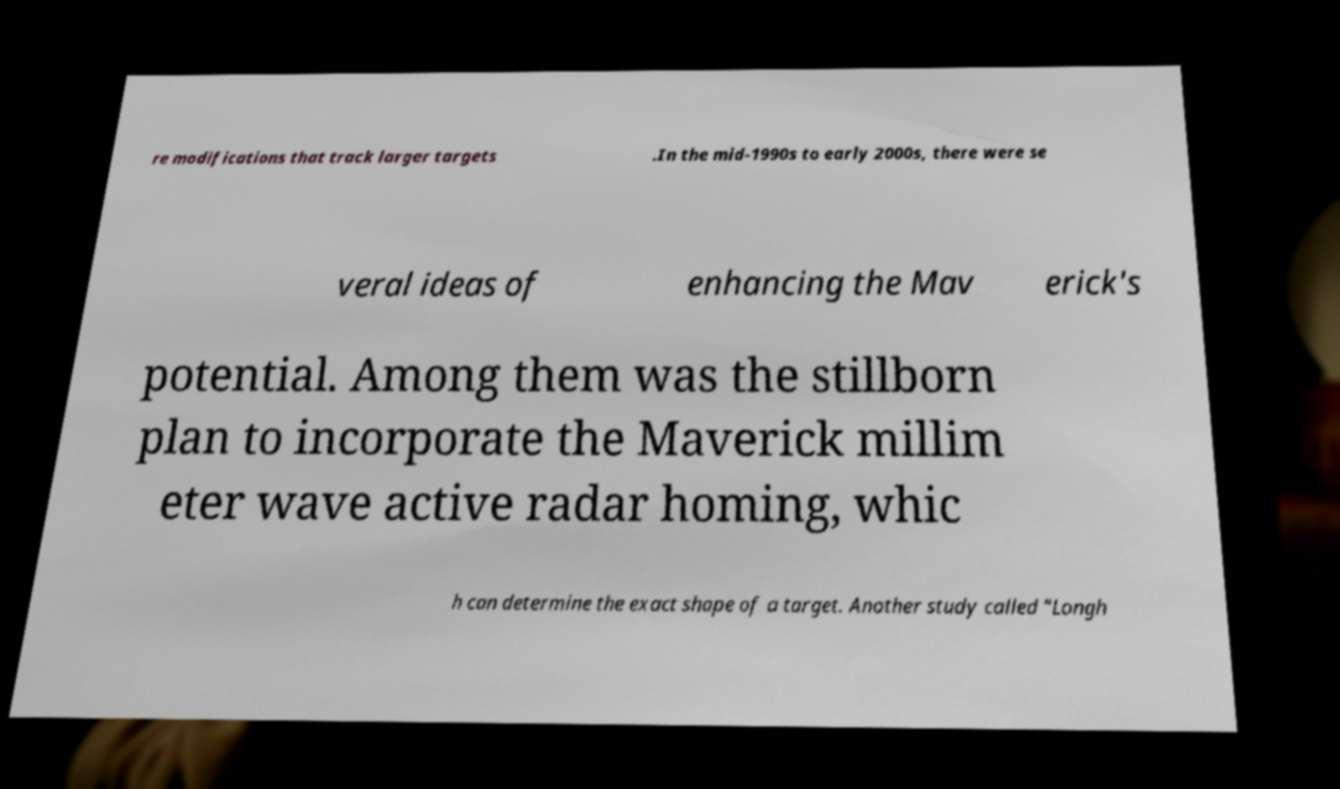For documentation purposes, I need the text within this image transcribed. Could you provide that? re modifications that track larger targets .In the mid-1990s to early 2000s, there were se veral ideas of enhancing the Mav erick's potential. Among them was the stillborn plan to incorporate the Maverick millim eter wave active radar homing, whic h can determine the exact shape of a target. Another study called "Longh 